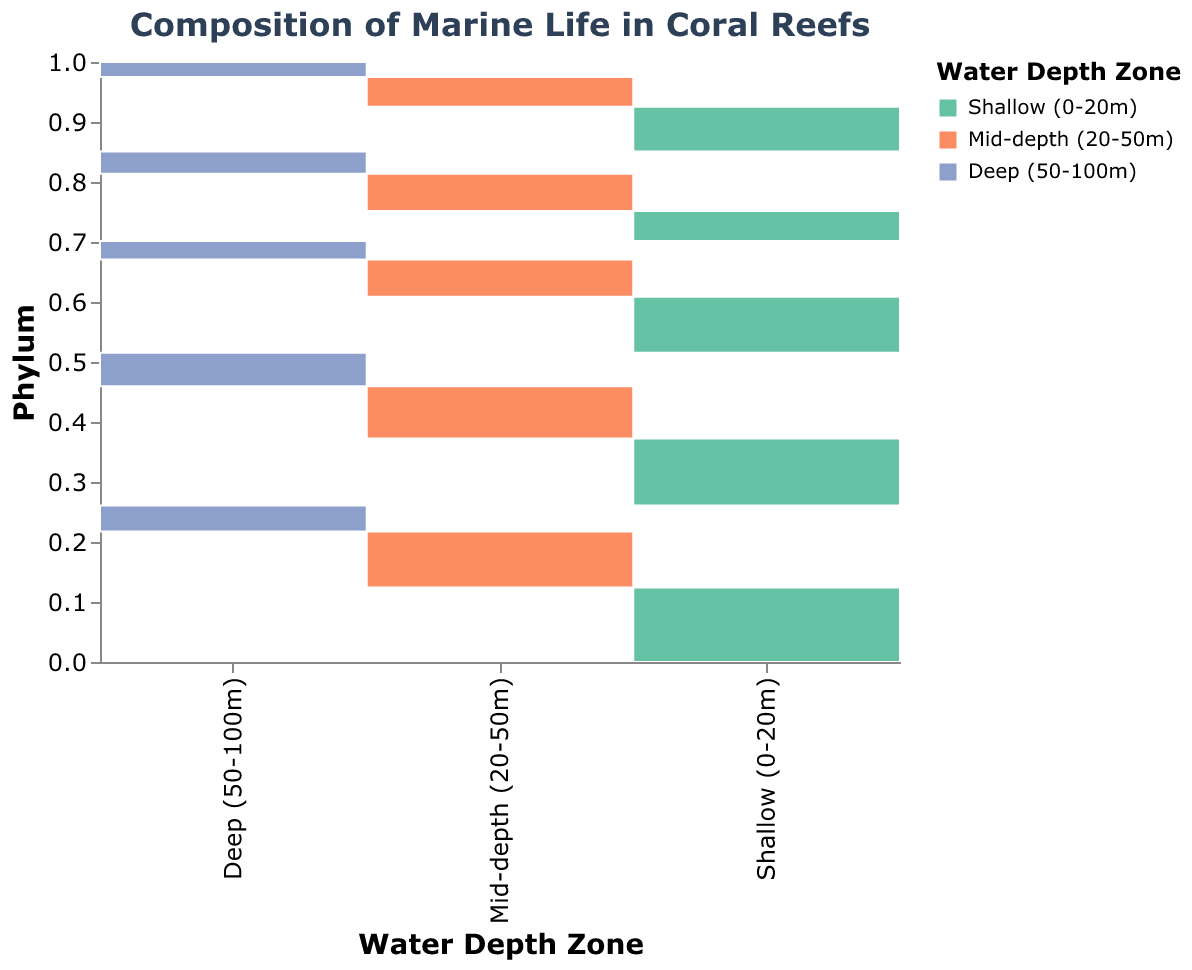What is the highest count of marine life in the shallow depth zone? By looking at the mosaic plot, observe the widest segment for the shallow depth zone, which is represented by the color for shallow zone and the phylum Arthropoda.
Answer: 200 Which phylum has the least count in the deep depth zone? For the deep zone, identify the narrowest segment in the plot. This segment corresponds to the Mollusca phylum.
Answer: Mollusca How many phyla have higher counts in the mid-depth zone compared to the deep zone? Compare each phylum's mid-depth counts with their deep counts. Both Cnidaria, Mollusca, Arthropoda, Echinodermata, and Chordata have higher counts in the mid-depth zone than in the deep zone.
Answer: 5 Which phylum shows the most uniform distribution across different depth zones? By examining the segments' widths across all depth zones, the Echinodermata phylum shows similar counts in shallow, mid-depth, and deep zones.
Answer: Echinodermata What is the total count of marine life in the shallow depth zone? Sum the counts for all phyla within the shallow depth zone: 150 (Cnidaria) + 120 (Mollusca) + 200 (Arthropoda) + 80 (Echinodermata) + 180 (Chordata). Sum is 150 + 120 + 200 + 80 + 180 = 730.
Answer: 730 Which phylum has the largest difference in count between shallow and deep zones? Calculate the count difference for each phylum between shallow and deep zones: 
    - Cnidaria: 150 - 50 = 100
    - Mollusca: 120 - 40 = 80
    - Arthropoda: 200 - 70 = 130
    - Echinodermata: 80 - 60 = 20
    - Chordata: 180 - 90 = 90
Arthropoda has the largest difference, which is 130.
Answer: Arthropoda Does any phylum have a higher count in the deep zone than in the shallow zone? Compare all phyla counts in deep and shallow zones. None of the phyla in the deep zone exceed their counts in the shallow zone.
Answer: No What is the proportion of Chordata in the mid-depth zone relative to the total mid-depth zone count? Mid-depth counts for all phyla add up: 100 (Cnidaria) + 80 (Mollusca) + 150 (Arthropoda) + 100 (Echinodermata) + 140 (Chordata) = 570. The proportion of Chordata is 140 / 570 ≈ 0.246
Answer: ≈ 0.246 